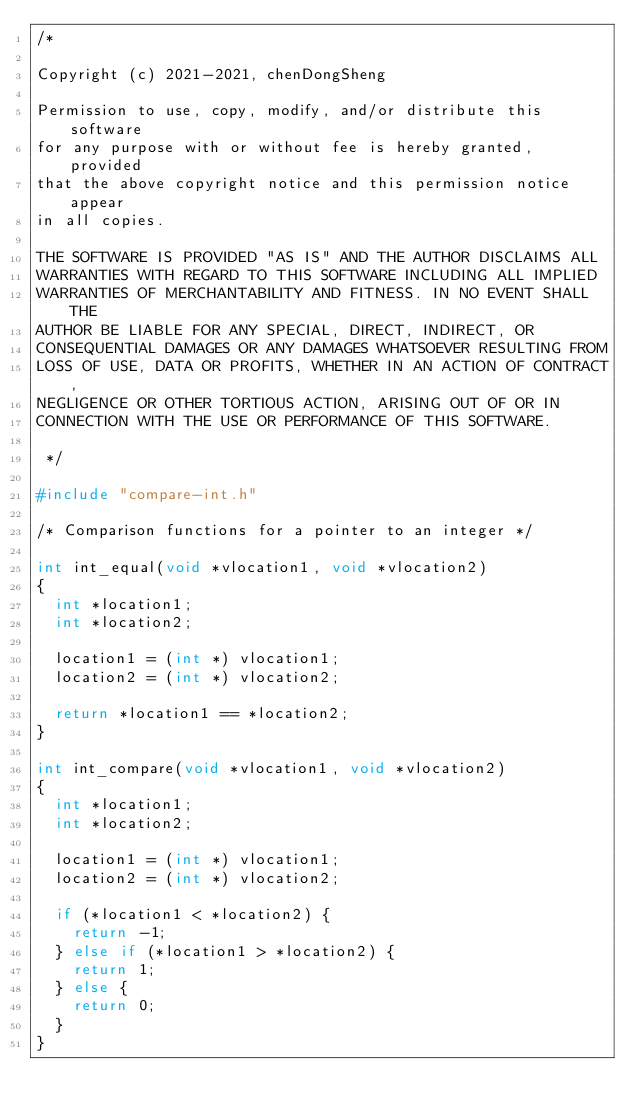Convert code to text. <code><loc_0><loc_0><loc_500><loc_500><_C_>/*

Copyright (c) 2021-2021, chenDongSheng

Permission to use, copy, modify, and/or distribute this software
for any purpose with or without fee is hereby granted, provided
that the above copyright notice and this permission notice appear
in all copies.

THE SOFTWARE IS PROVIDED "AS IS" AND THE AUTHOR DISCLAIMS ALL
WARRANTIES WITH REGARD TO THIS SOFTWARE INCLUDING ALL IMPLIED
WARRANTIES OF MERCHANTABILITY AND FITNESS. IN NO EVENT SHALL THE
AUTHOR BE LIABLE FOR ANY SPECIAL, DIRECT, INDIRECT, OR
CONSEQUENTIAL DAMAGES OR ANY DAMAGES WHATSOEVER RESULTING FROM
LOSS OF USE, DATA OR PROFITS, WHETHER IN AN ACTION OF CONTRACT,
NEGLIGENCE OR OTHER TORTIOUS ACTION, ARISING OUT OF OR IN
CONNECTION WITH THE USE OR PERFORMANCE OF THIS SOFTWARE.

 */

#include "compare-int.h"

/* Comparison functions for a pointer to an integer */

int int_equal(void *vlocation1, void *vlocation2)
{
	int *location1;
	int *location2;

	location1 = (int *) vlocation1;
	location2 = (int *) vlocation2;

	return *location1 == *location2;
}

int int_compare(void *vlocation1, void *vlocation2)
{
	int *location1;
	int *location2;

	location1 = (int *) vlocation1;
	location2 = (int *) vlocation2;

	if (*location1 < *location2) {
		return -1;
	} else if (*location1 > *location2) {
		return 1;
	} else {
		return 0;
	}
}


</code> 